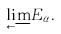Convert formula to latex. <formula><loc_0><loc_0><loc_500><loc_500>\underset { \longleftarrow } { \lim } E _ { \alpha } .</formula> 